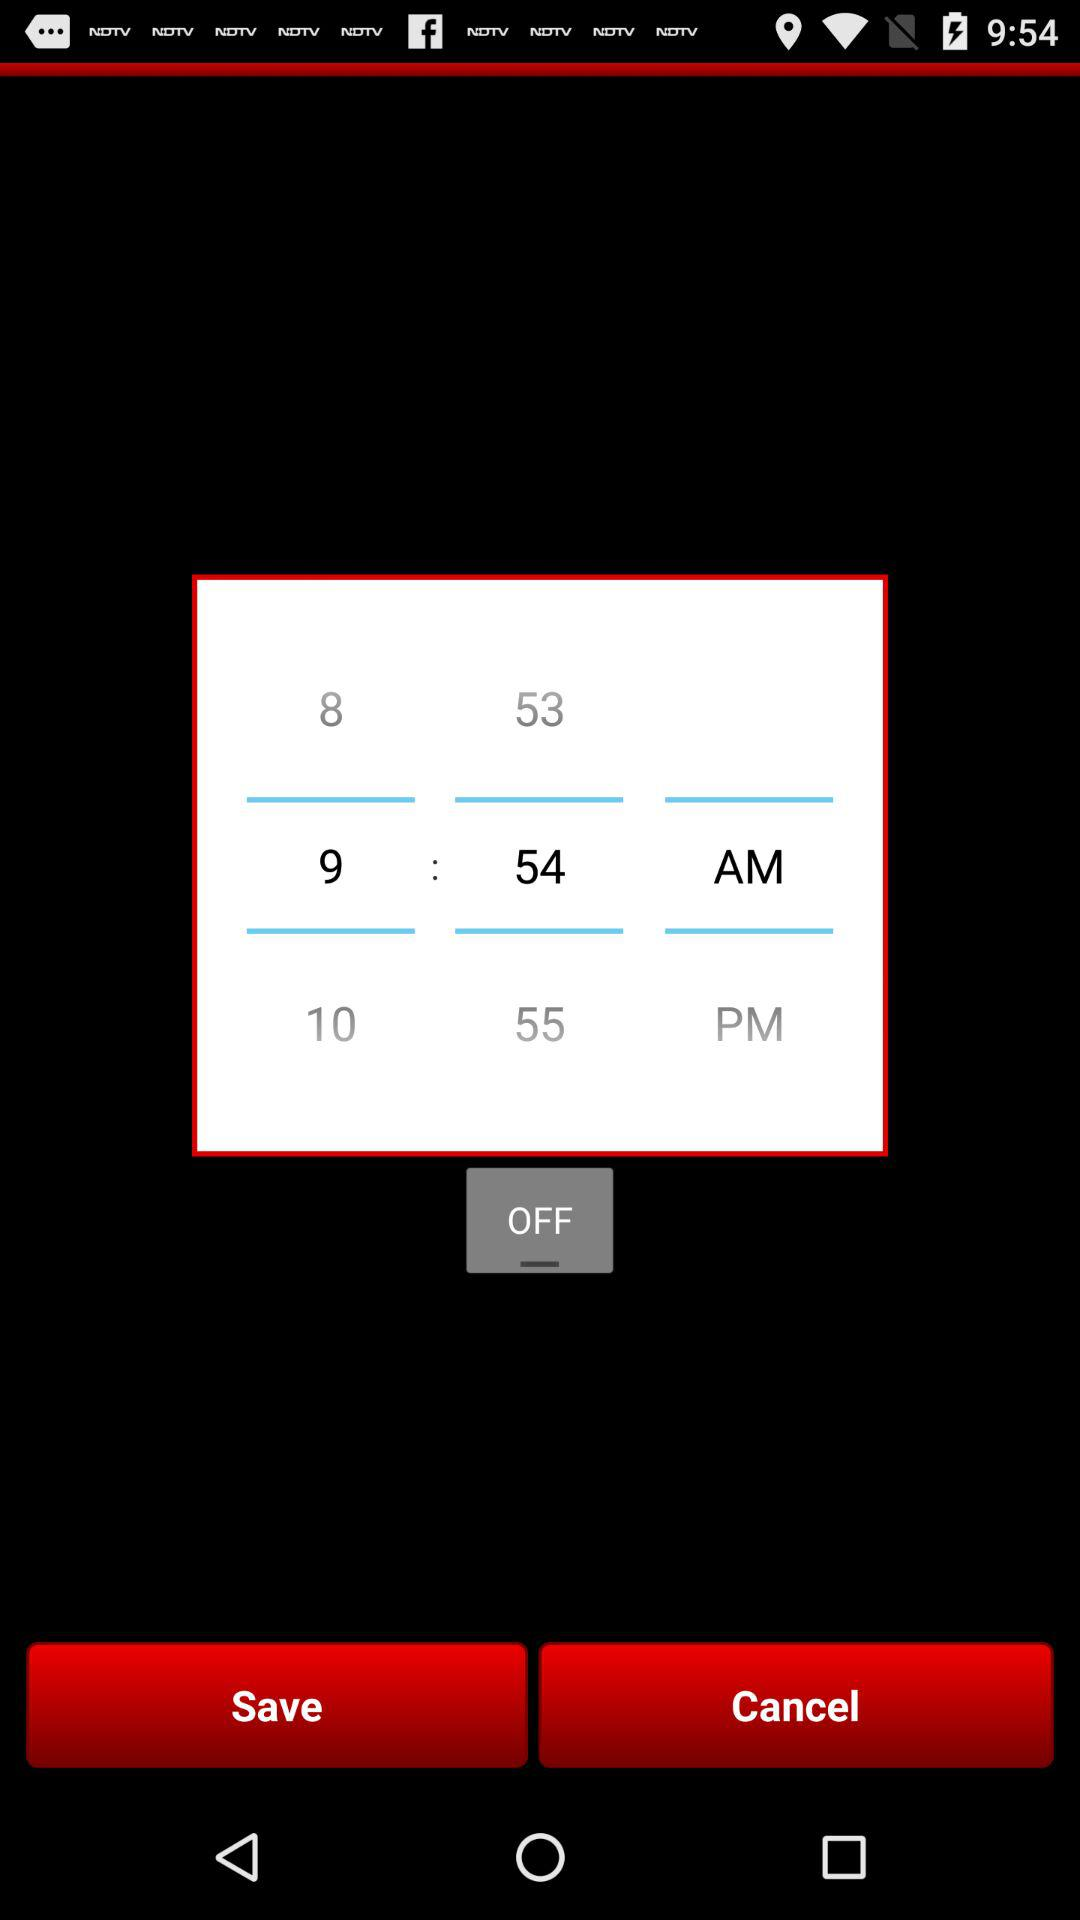What is the selected time? The selected time is 9:54 AM. 